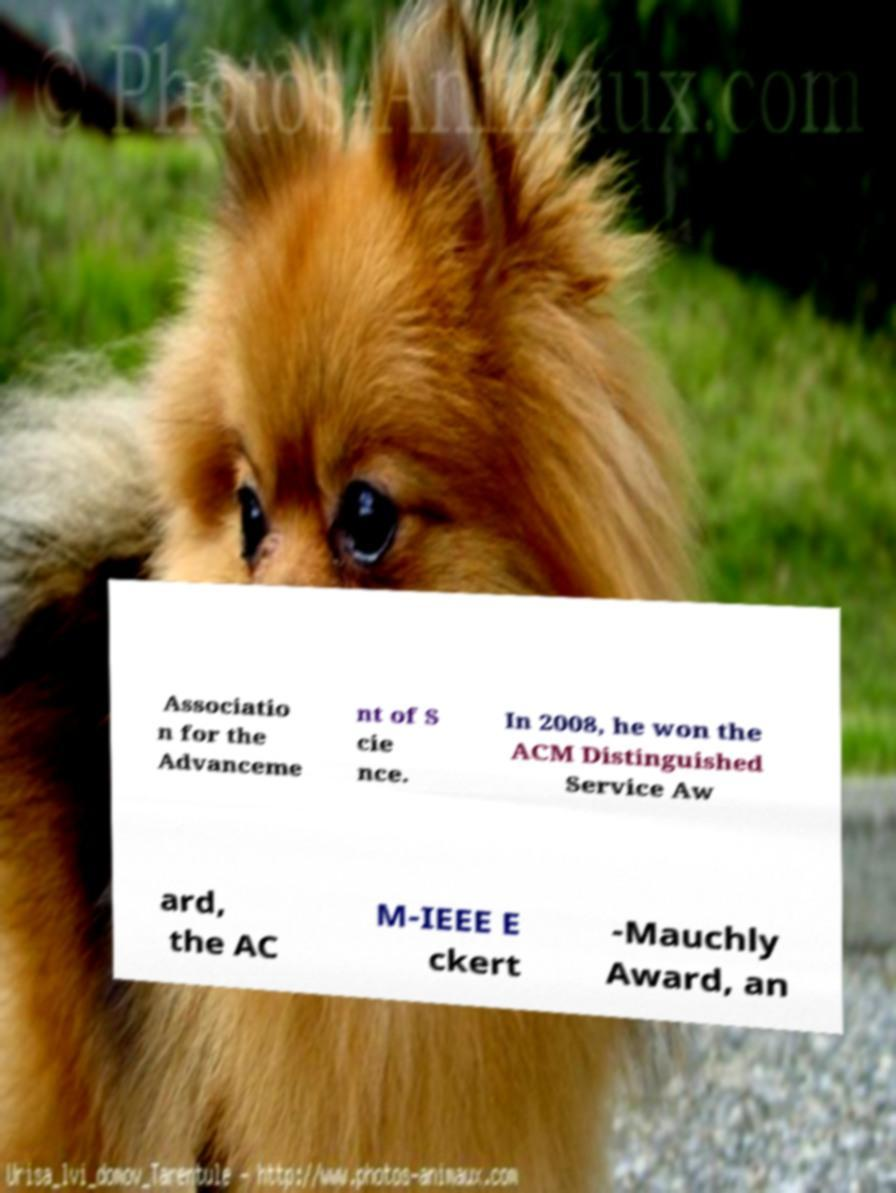There's text embedded in this image that I need extracted. Can you transcribe it verbatim? Associatio n for the Advanceme nt of S cie nce. In 2008, he won the ACM Distinguished Service Aw ard, the AC M-IEEE E ckert -Mauchly Award, an 